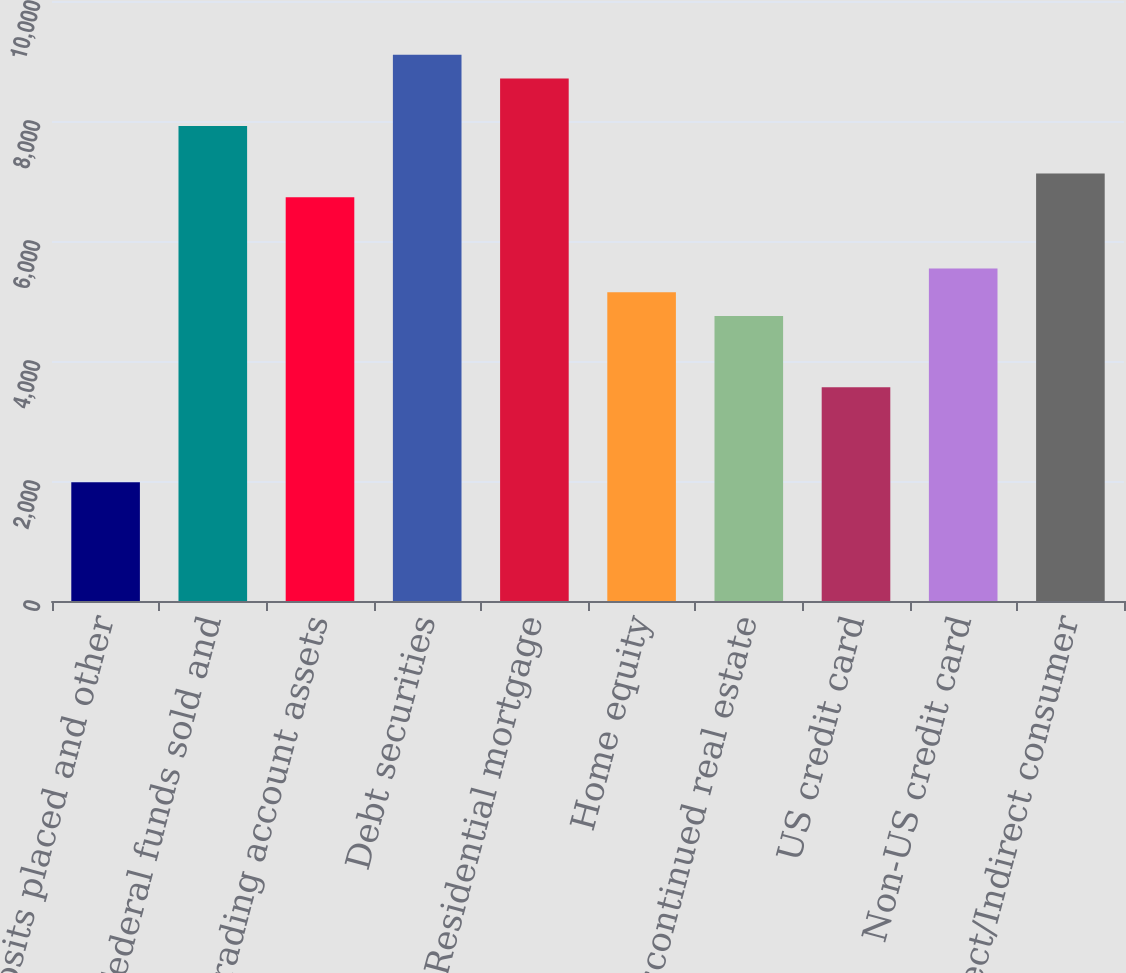Convert chart to OTSL. <chart><loc_0><loc_0><loc_500><loc_500><bar_chart><fcel>Time deposits placed and other<fcel>Federal funds sold and<fcel>Trading account assets<fcel>Debt securities<fcel>Residential mortgage<fcel>Home equity<fcel>Discontinued real estate<fcel>US credit card<fcel>Non-US credit card<fcel>Direct/Indirect consumer<nl><fcel>1980<fcel>7917<fcel>6729.6<fcel>9104.4<fcel>8708.6<fcel>5146.4<fcel>4750.6<fcel>3563.2<fcel>5542.2<fcel>7125.4<nl></chart> 